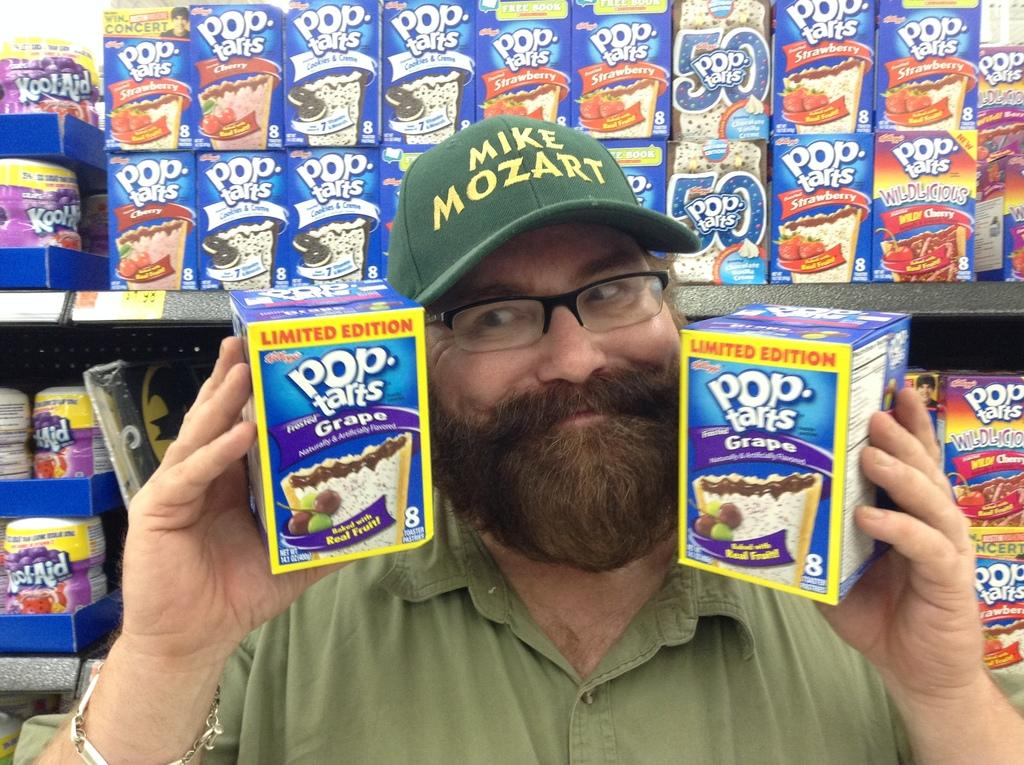Who is present in the image? There is a man in the image. What is the man holding in his hands? The man is holding boxes in his hands. What is the man wearing on his upper body? The man is wearing a shirt. What is the man wearing on his head? The man is wearing a cap. What is the man wearing on his face? The man is wearing spectacles. What can be seen in the background of the image? There are boxes on shelves in the background of the image. What type of scarf is the man wearing in the image? There is no scarf present in the image; the man is wearing a shirt and a cap. How many pigs can be seen in the image? There are no pigs present in the image; the man is holding boxes and there are boxes on shelves in the background. 